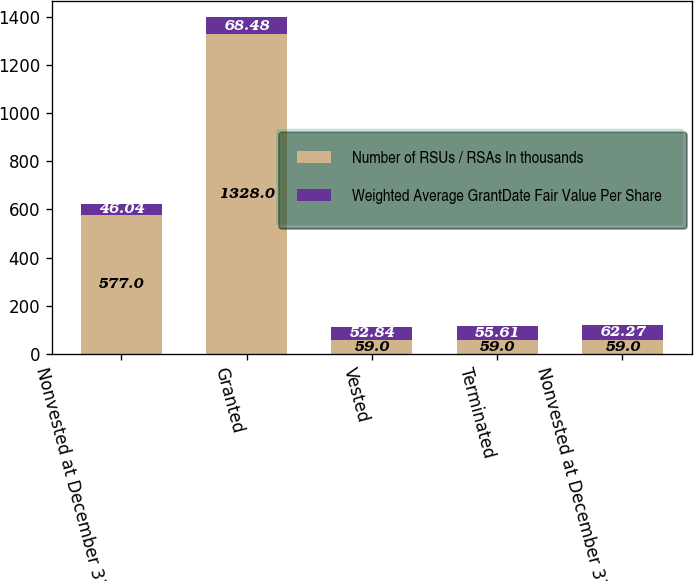Convert chart. <chart><loc_0><loc_0><loc_500><loc_500><stacked_bar_chart><ecel><fcel>Nonvested at December 31 2005<fcel>Granted<fcel>Vested<fcel>Terminated<fcel>Nonvested at December 31 2006<nl><fcel>Number of RSUs / RSAs In thousands<fcel>577<fcel>1328<fcel>59<fcel>59<fcel>59<nl><fcel>Weighted Average GrantDate Fair Value Per Share<fcel>46.04<fcel>68.48<fcel>52.84<fcel>55.61<fcel>62.27<nl></chart> 